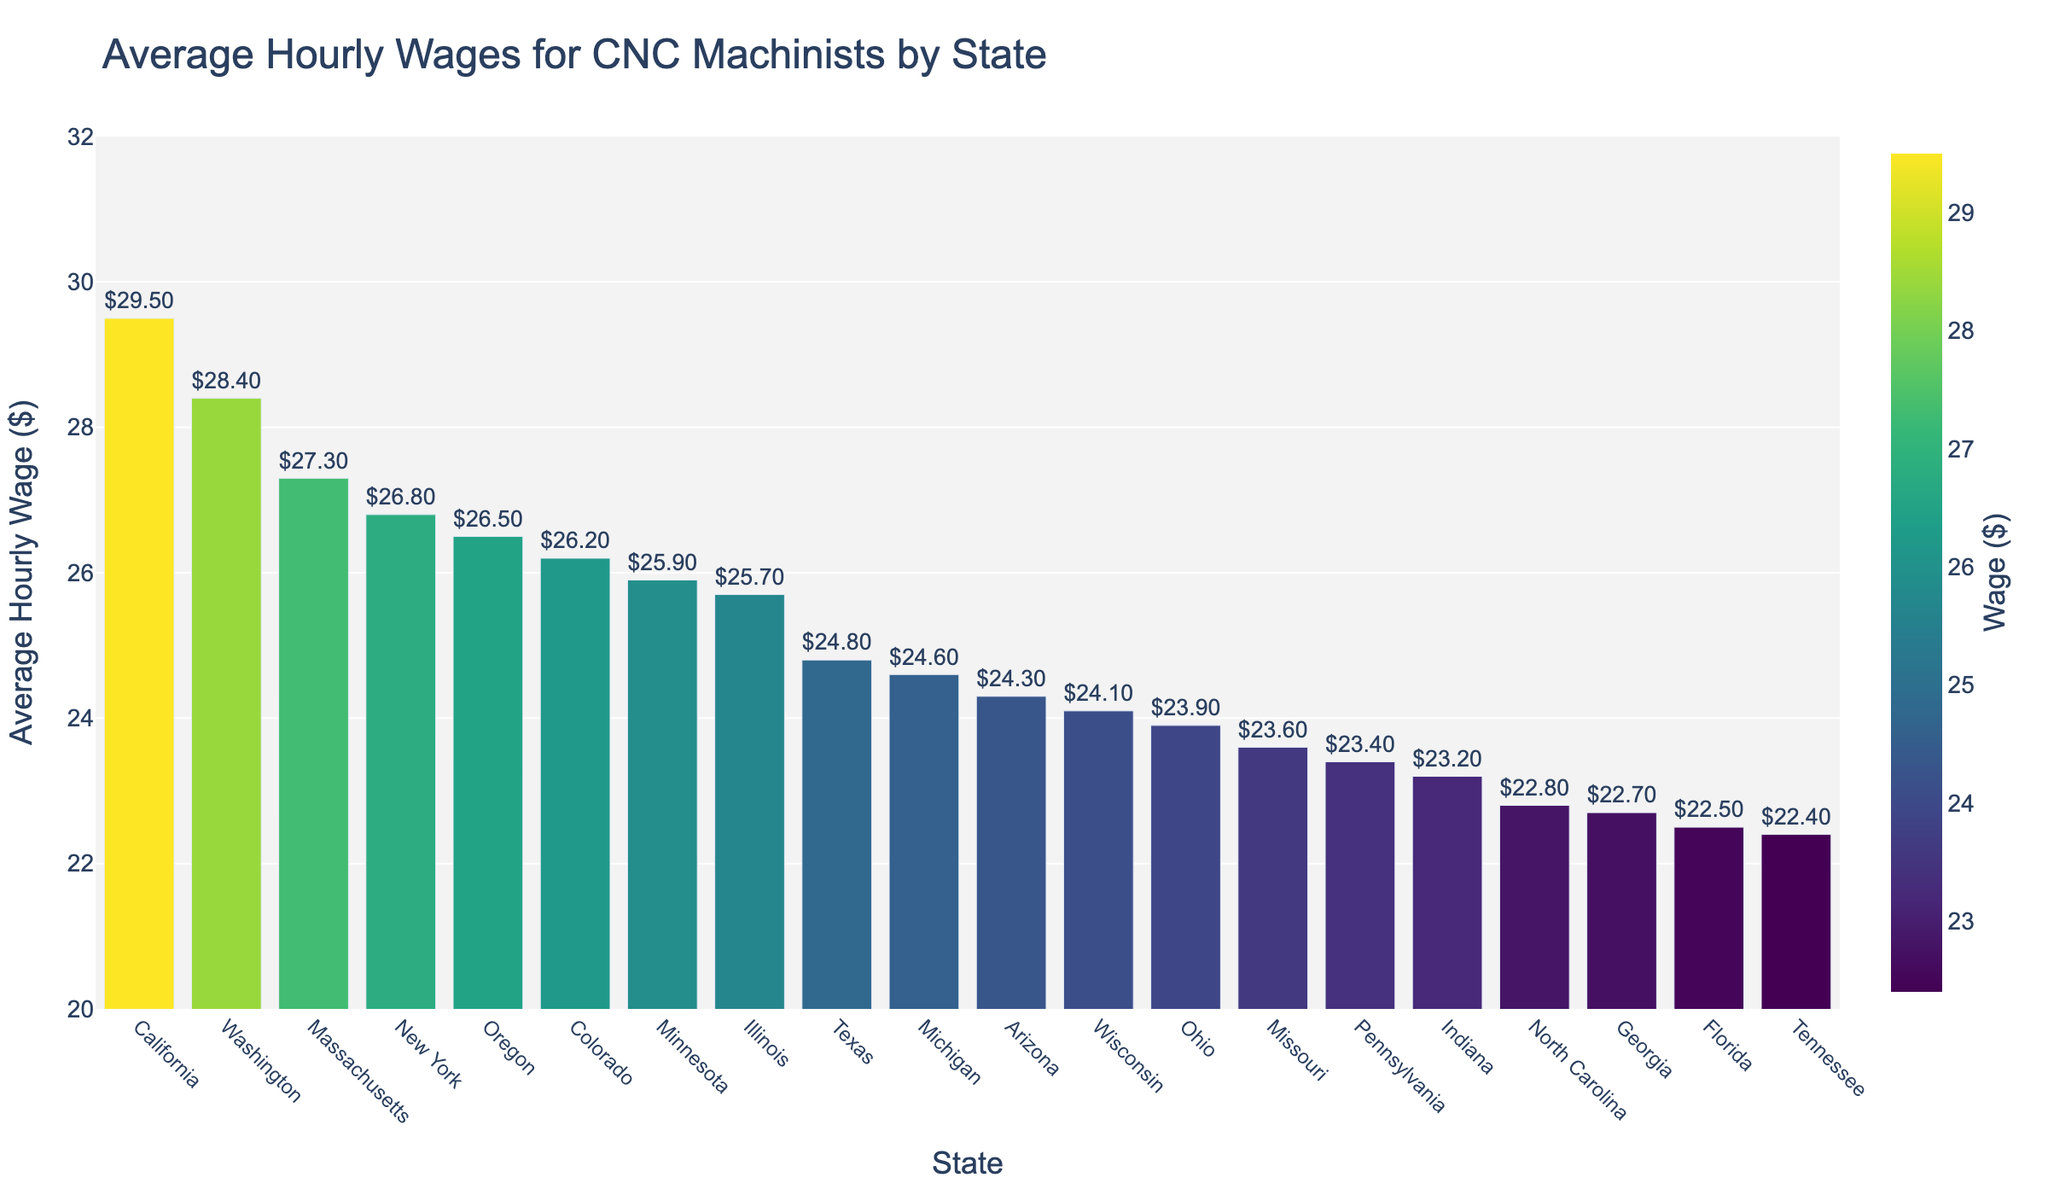What's the state with the highest average hourly wage for CNC machinists? Look at the bar that represents the state with the highest height, which is California.
Answer: California Which state has a lower average hourly wage, Ohio or Illinois? Compare the height of the bars for Ohio and Illinois. Ohio's bar is shorter than Illinois'.
Answer: Ohio What is the difference in average hourly wage between the highest and lowest paying states? California has the highest average hourly wage ($29.50), and Tennessee has the lowest ($22.40). The difference is $29.50 - $22.40 = $7.10.
Answer: $7.10 How many states have an average hourly wage greater than $25? Identify the bars that exceed the $25 mark. Those states are California, Washington, New York, Massachusetts, Oregon, Colorado, Minnesota, Illinois. There are 8 such states.
Answer: 8 Which state closest to an average hourly wage of $24? Look for the state with the bar closest to the $24 mark. Wisconsin's bar is at $24.10, which is closest.
Answer: Wisconsin Which state has an average hourly wage equal to $24.80? Identify the bar labeled with $24.80. It's Texas.
Answer: Texas What's the combined average hourly wage for Michigan and Pennsylvania? Sum the values for Michigan ($24.60) and Pennsylvania ($23.40). The total is $24.60 + $23.40 = $48.00.
Answer: $48.00 How much does the average hourly wage for New York exceed that of Florida? Subtract Florida's average hourly wage ($22.50) from New York's ($26.80). The difference is $26.80 - $22.50 = $4.30.
Answer: $4.30 